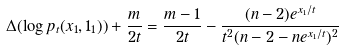Convert formula to latex. <formula><loc_0><loc_0><loc_500><loc_500>\Delta ( \log p _ { t } ( x _ { 1 } , 1 _ { 1 } ) ) + \frac { m } { 2 t } = \frac { m - 1 } { 2 t } - \frac { ( n - 2 ) e ^ { x _ { 1 } / t } } { t ^ { 2 } ( n - 2 - n e ^ { x _ { 1 } / t } ) ^ { 2 } }</formula> 